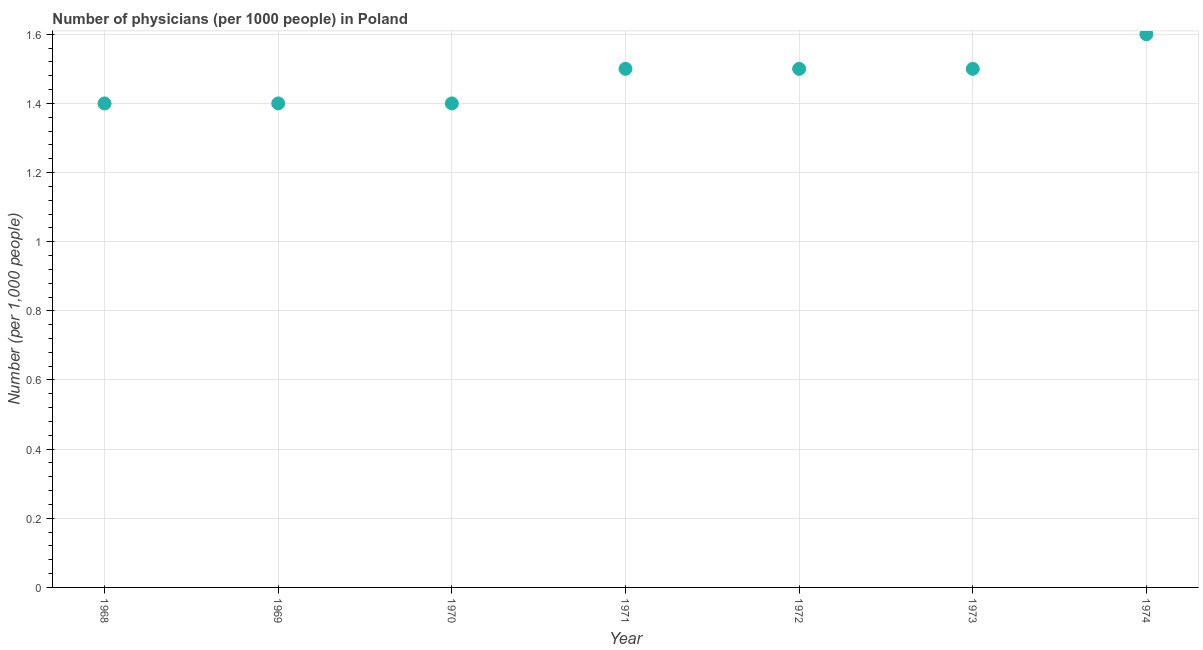What is the number of physicians in 1974?
Your answer should be very brief. 1.6. Across all years, what is the maximum number of physicians?
Make the answer very short. 1.6. Across all years, what is the minimum number of physicians?
Offer a very short reply. 1.4. In which year was the number of physicians maximum?
Make the answer very short. 1974. In which year was the number of physicians minimum?
Keep it short and to the point. 1968. What is the sum of the number of physicians?
Your answer should be very brief. 10.3. What is the difference between the number of physicians in 1972 and 1974?
Offer a terse response. -0.1. What is the average number of physicians per year?
Provide a succinct answer. 1.47. In how many years, is the number of physicians greater than 0.08 ?
Offer a very short reply. 7. Do a majority of the years between 1971 and 1974 (inclusive) have number of physicians greater than 1.36 ?
Keep it short and to the point. Yes. What is the ratio of the number of physicians in 1968 to that in 1969?
Your response must be concise. 1. Is the difference between the number of physicians in 1970 and 1973 greater than the difference between any two years?
Your answer should be very brief. No. What is the difference between the highest and the second highest number of physicians?
Offer a very short reply. 0.1. Is the sum of the number of physicians in 1969 and 1972 greater than the maximum number of physicians across all years?
Provide a short and direct response. Yes. What is the difference between the highest and the lowest number of physicians?
Keep it short and to the point. 0.2. How many years are there in the graph?
Make the answer very short. 7. What is the difference between two consecutive major ticks on the Y-axis?
Your answer should be compact. 0.2. Does the graph contain grids?
Offer a terse response. Yes. What is the title of the graph?
Your answer should be compact. Number of physicians (per 1000 people) in Poland. What is the label or title of the Y-axis?
Your answer should be very brief. Number (per 1,0 people). What is the Number (per 1,000 people) in 1968?
Your answer should be compact. 1.4. What is the Number (per 1,000 people) in 1970?
Your answer should be very brief. 1.4. What is the Number (per 1,000 people) in 1972?
Keep it short and to the point. 1.5. What is the Number (per 1,000 people) in 1973?
Your answer should be very brief. 1.5. What is the difference between the Number (per 1,000 people) in 1968 and 1969?
Give a very brief answer. 0. What is the difference between the Number (per 1,000 people) in 1968 and 1971?
Provide a succinct answer. -0.1. What is the difference between the Number (per 1,000 people) in 1968 and 1972?
Keep it short and to the point. -0.1. What is the difference between the Number (per 1,000 people) in 1968 and 1973?
Keep it short and to the point. -0.1. What is the difference between the Number (per 1,000 people) in 1968 and 1974?
Keep it short and to the point. -0.2. What is the difference between the Number (per 1,000 people) in 1969 and 1970?
Give a very brief answer. 0. What is the difference between the Number (per 1,000 people) in 1969 and 1973?
Your answer should be compact. -0.1. What is the difference between the Number (per 1,000 people) in 1969 and 1974?
Provide a succinct answer. -0.2. What is the difference between the Number (per 1,000 people) in 1970 and 1971?
Your answer should be very brief. -0.1. What is the difference between the Number (per 1,000 people) in 1970 and 1974?
Keep it short and to the point. -0.2. What is the difference between the Number (per 1,000 people) in 1971 and 1972?
Your answer should be compact. 0. What is the difference between the Number (per 1,000 people) in 1971 and 1973?
Provide a succinct answer. 0. What is the difference between the Number (per 1,000 people) in 1972 and 1974?
Provide a short and direct response. -0.1. What is the ratio of the Number (per 1,000 people) in 1968 to that in 1969?
Offer a very short reply. 1. What is the ratio of the Number (per 1,000 people) in 1968 to that in 1971?
Your answer should be very brief. 0.93. What is the ratio of the Number (per 1,000 people) in 1968 to that in 1972?
Provide a succinct answer. 0.93. What is the ratio of the Number (per 1,000 people) in 1968 to that in 1973?
Your answer should be very brief. 0.93. What is the ratio of the Number (per 1,000 people) in 1969 to that in 1971?
Provide a succinct answer. 0.93. What is the ratio of the Number (per 1,000 people) in 1969 to that in 1972?
Offer a terse response. 0.93. What is the ratio of the Number (per 1,000 people) in 1969 to that in 1973?
Your answer should be compact. 0.93. What is the ratio of the Number (per 1,000 people) in 1969 to that in 1974?
Offer a very short reply. 0.88. What is the ratio of the Number (per 1,000 people) in 1970 to that in 1971?
Give a very brief answer. 0.93. What is the ratio of the Number (per 1,000 people) in 1970 to that in 1972?
Your answer should be compact. 0.93. What is the ratio of the Number (per 1,000 people) in 1970 to that in 1973?
Provide a short and direct response. 0.93. What is the ratio of the Number (per 1,000 people) in 1971 to that in 1972?
Ensure brevity in your answer.  1. What is the ratio of the Number (per 1,000 people) in 1971 to that in 1973?
Make the answer very short. 1. What is the ratio of the Number (per 1,000 people) in 1971 to that in 1974?
Your response must be concise. 0.94. What is the ratio of the Number (per 1,000 people) in 1972 to that in 1973?
Keep it short and to the point. 1. What is the ratio of the Number (per 1,000 people) in 1972 to that in 1974?
Keep it short and to the point. 0.94. What is the ratio of the Number (per 1,000 people) in 1973 to that in 1974?
Give a very brief answer. 0.94. 